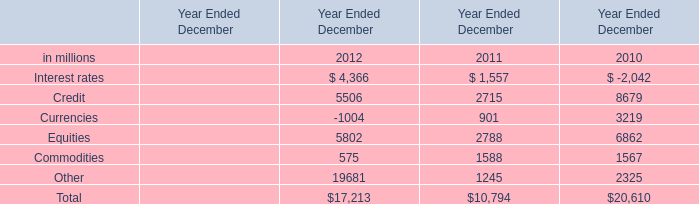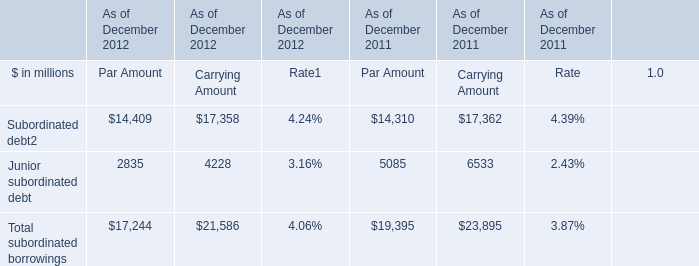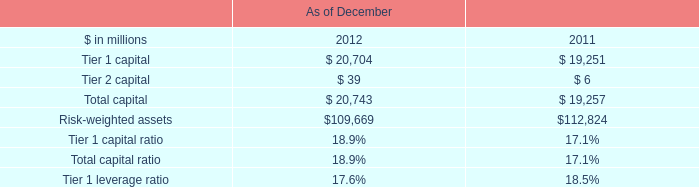What is the sum of Junior subordinated debt of As of December 2011 Par Amount, and Interest rates of Year Ended December 2010 is ? 
Computations: (5085.0 + 2042.0)
Answer: 7127.0. 